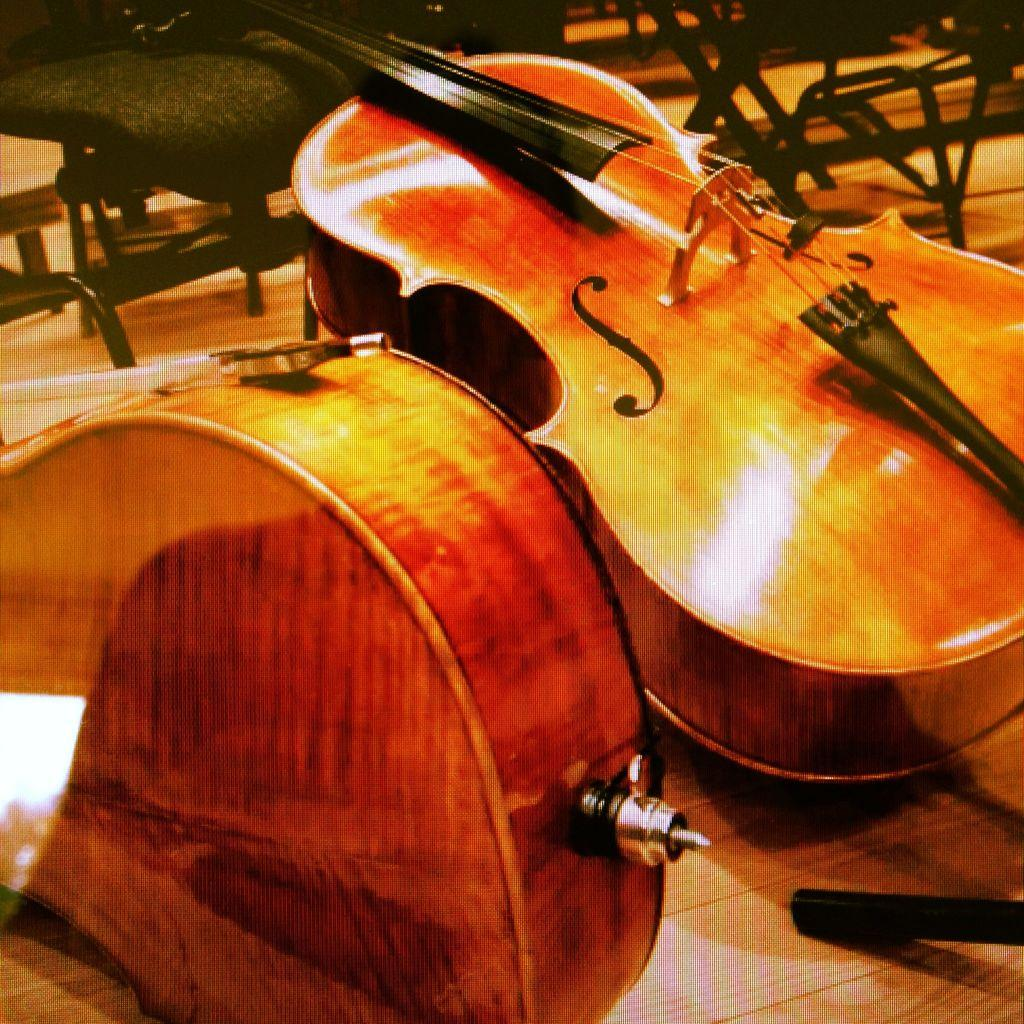What musical instruments are present in the image? There are two violins in the image. What can be seen in the background of the image? There are many chairs in the background of the image. Is there any text or lettering on any of the violins? Yes, the letter "S" is written on one of the violins. What type of pets are visible in the image? There are no pets present in the image. Who is the creator of the violins in the image? The image does not provide information about the creator of the violins. 